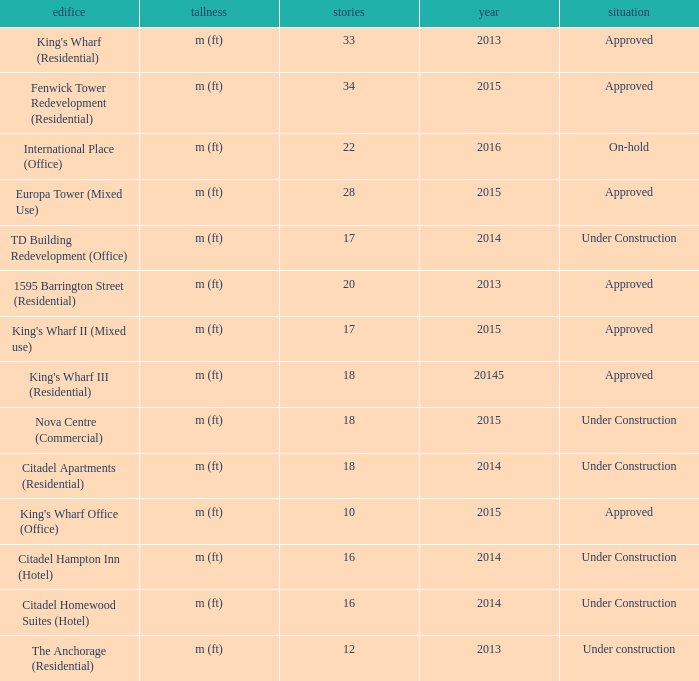What is the status of the building with less than 18 floors and later than 2013? Under Construction, Approved, Approved, Under Construction, Under Construction. 